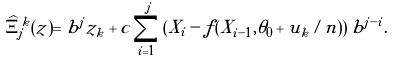Convert formula to latex. <formula><loc_0><loc_0><loc_500><loc_500>\widehat { \Xi } ^ { k } _ { j } ( z ) = b ^ { j } z _ { k } + c \sum _ { i = 1 } ^ { j } \left ( X _ { i } - f ( X _ { i - 1 } , \theta _ { 0 } + u _ { k } / n ) \right ) b ^ { j - i } .</formula> 